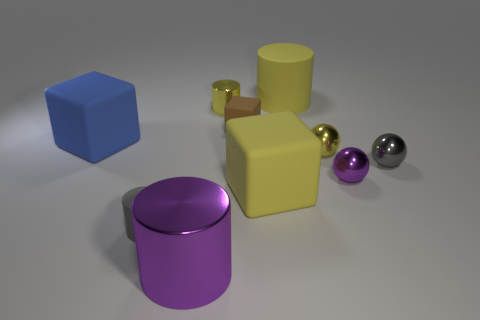Are there more small metal things than purple metallic spheres?
Ensure brevity in your answer.  Yes. How many small yellow objects are made of the same material as the tiny yellow cylinder?
Offer a very short reply. 1. Is the shape of the blue rubber object the same as the big metallic object?
Your answer should be compact. No. How big is the block in front of the small gray object that is right of the large cylinder that is in front of the gray ball?
Offer a very short reply. Large. Are there any rubber objects that are to the right of the gray object behind the small gray rubber object?
Give a very brief answer. No. How many blue objects are behind the metal cylinder that is in front of the big block that is in front of the tiny purple ball?
Your answer should be compact. 1. The big rubber object that is both behind the purple metallic sphere and right of the blue rubber thing is what color?
Offer a terse response. Yellow. How many blocks have the same color as the large metal cylinder?
Offer a very short reply. 0. How many cylinders are gray shiny objects or big purple shiny objects?
Offer a terse response. 1. The rubber block that is the same size as the yellow metal sphere is what color?
Provide a succinct answer. Brown. 